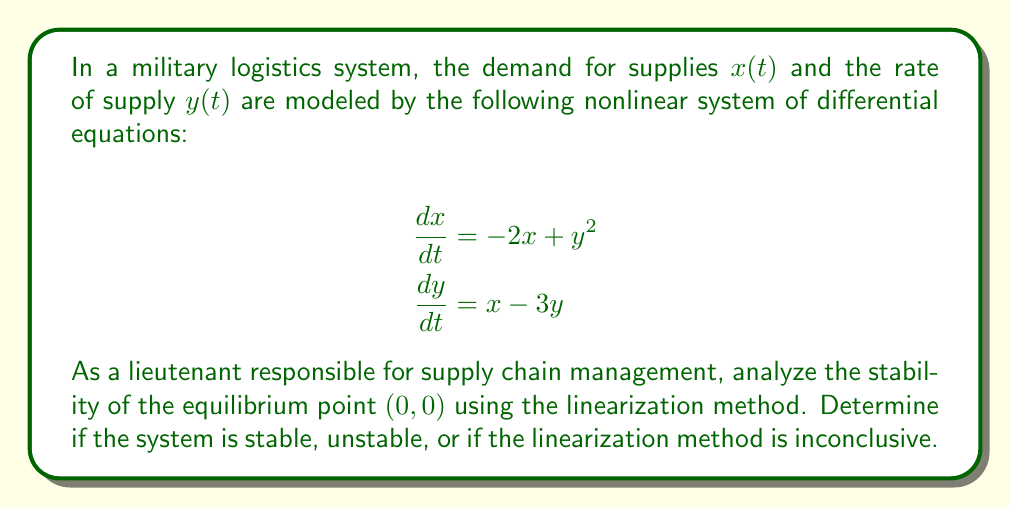Provide a solution to this math problem. To analyze the stability of the nonlinear system at the equilibrium point $(0,0)$, we'll follow these steps:

1. Verify that $(0,0)$ is indeed an equilibrium point:
   Substitute $x=0$ and $y=0$ into both equations:
   $\frac{dx}{dt} = -2(0) + 0^2 = 0$
   $\frac{dy}{dt} = 0 - 3(0) = 0$
   Both equations equal zero, confirming $(0,0)$ is an equilibrium point.

2. Compute the Jacobian matrix at $(0,0)$:
   $J = \begin{bmatrix}
   \frac{\partial f_1}{\partial x} & \frac{\partial f_1}{\partial y} \\
   \frac{\partial f_2}{\partial x} & \frac{\partial f_2}{\partial y}
   \end{bmatrix} = \begin{bmatrix}
   -2 & 2y \\
   1 & -3
   \end{bmatrix}$

   Evaluate at $(0,0)$:
   $J(0,0) = \begin{bmatrix}
   -2 & 0 \\
   1 & -3
   \end{bmatrix}$

3. Find the eigenvalues of $J(0,0)$:
   $det(J(0,0) - \lambda I) = \begin{vmatrix}
   -2-\lambda & 0 \\
   1 & -3-\lambda
   \end{vmatrix} = (-2-\lambda)(-3-\lambda) = 0$

   $\lambda^2 + 5\lambda + 6 = 0$
   $(\lambda + 2)(\lambda + 3) = 0$
   $\lambda_1 = -2$ and $\lambda_2 = -3$

4. Analyze the eigenvalues:
   Both eigenvalues are real and negative.

5. Conclude on stability:
   Since both eigenvalues have negative real parts, the linearized system is asymptotically stable at $(0,0)$. By the Hartman-Grobman Theorem, this implies that the original nonlinear system is also asymptotically stable at $(0,0)$.
Answer: The system is asymptotically stable at $(0,0)$. 